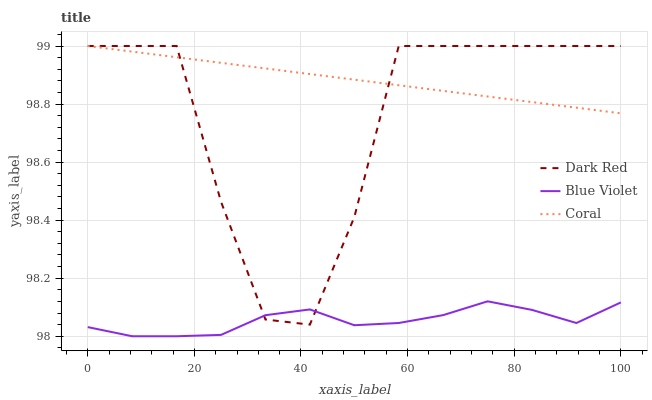Does Coral have the minimum area under the curve?
Answer yes or no. No. Does Blue Violet have the maximum area under the curve?
Answer yes or no. No. Is Blue Violet the smoothest?
Answer yes or no. No. Is Blue Violet the roughest?
Answer yes or no. No. Does Coral have the lowest value?
Answer yes or no. No. Does Blue Violet have the highest value?
Answer yes or no. No. Is Blue Violet less than Coral?
Answer yes or no. Yes. Is Coral greater than Blue Violet?
Answer yes or no. Yes. Does Blue Violet intersect Coral?
Answer yes or no. No. 